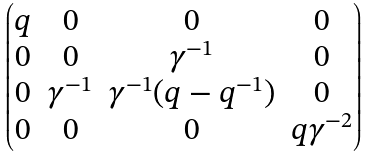Convert formula to latex. <formula><loc_0><loc_0><loc_500><loc_500>\begin{pmatrix} q & 0 & 0 & 0 \\ 0 & 0 & \gamma ^ { - 1 } & 0 \\ 0 & \gamma ^ { - 1 } & \gamma ^ { - 1 } ( q - q ^ { - 1 } ) & 0 \\ 0 & 0 & 0 & q \gamma ^ { - 2 } \end{pmatrix}</formula> 